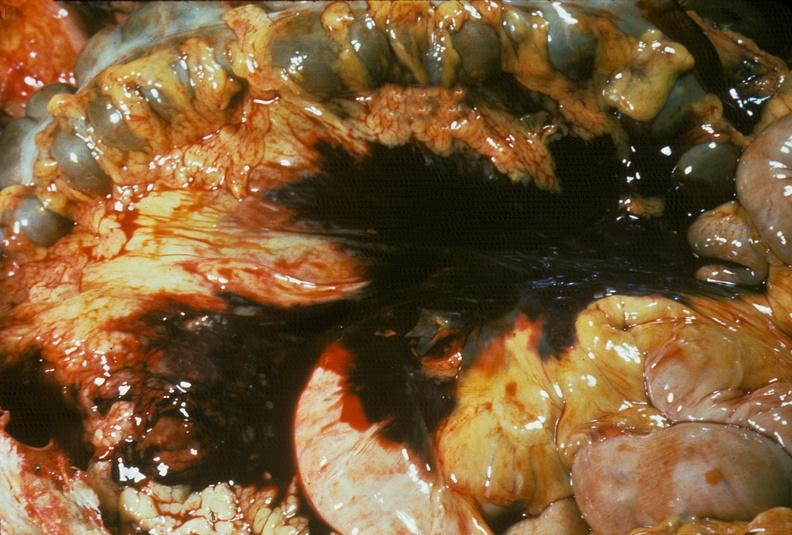does this image show hemorrhage secondary to ruptured aneurysm?
Answer the question using a single word or phrase. Yes 